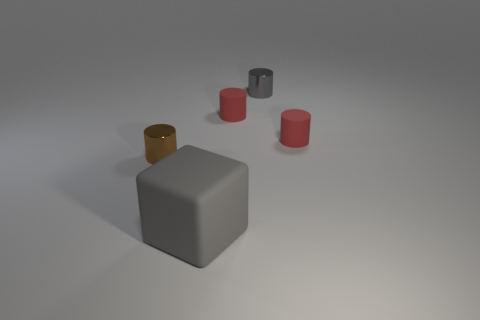What materials do the objects in the image appear to be made from? The objects in the image appear to be made from different materials. The glossy brown cylinder and the shiny dark cylinder suggest metallic surfaces, possibly polished steel or bronze for the brown one. The matte gray object looks like it could be made of stone or ceramic, attributing to its non-reflective surface. The red cylinders have a smooth, perhaps plastic-like finish. Is there any significance to the arrangement of these objects? The arrangement of objects could be interpreted as a study in contrast and balance, demonstrating how different textures and forms interact within a space. The variation in color and material creates a visually stimulating scene that might evoke different feelings or thoughts about harmony and asymmetry in everyday objects. 